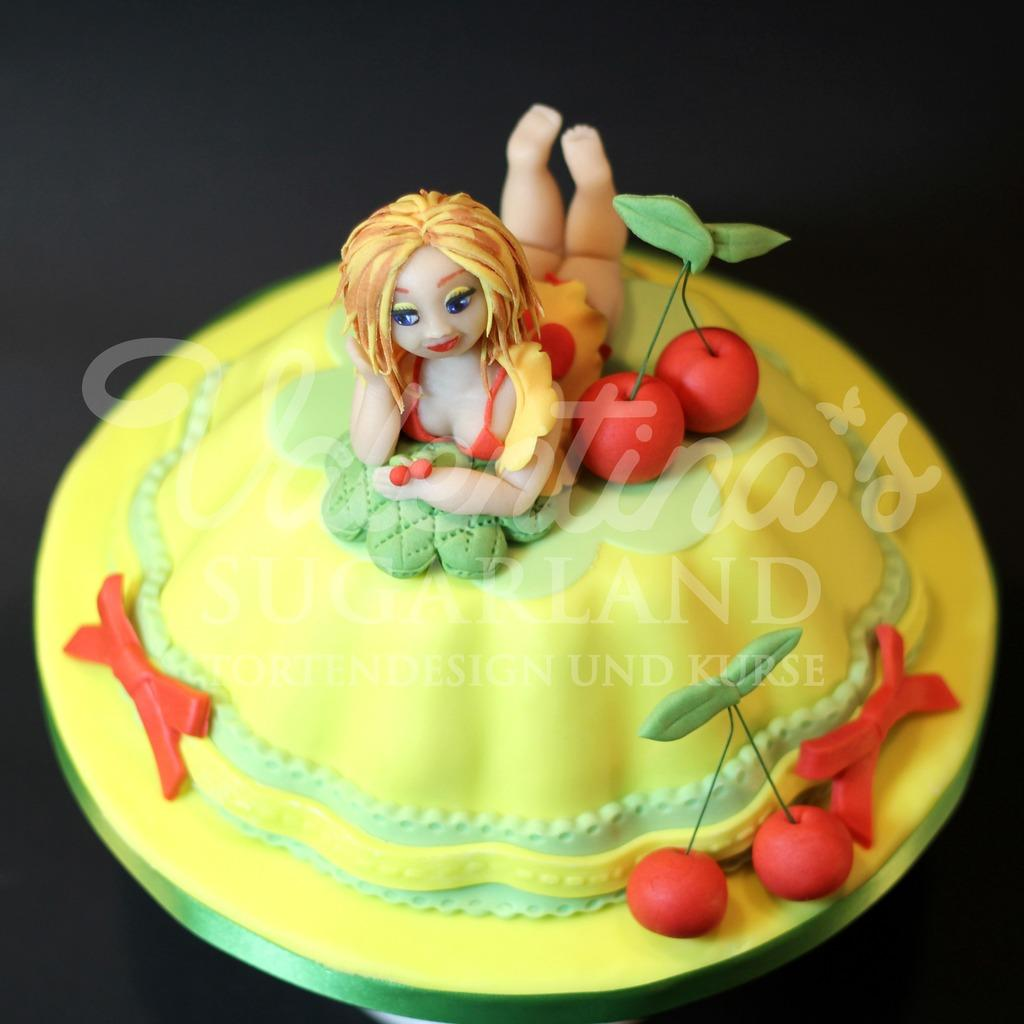What is the main subject of the image? The main subject of the image is a cake. What is unique about the design of the cake? The cake has structures carved into it, representing fruits and a woman. What type of baseball equipment can be seen in the image? There is no baseball equipment present in the image; it features a cake with carved structures representing fruits and a woman. What type of root is visible in the image? There are no roots visible in the image; it features a cake with carved structures representing fruits and a woman. 